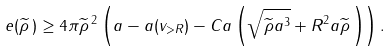Convert formula to latex. <formula><loc_0><loc_0><loc_500><loc_500>e ( \widetilde { \rho } \, ) \geq 4 \pi \widetilde { \rho } \, ^ { 2 } \left ( a - a ( v _ { > R } ) - C a \left ( \sqrt { \widetilde { \rho } a ^ { 3 } } + R ^ { 2 } a \widetilde { \rho } \, \right ) \right ) .</formula> 